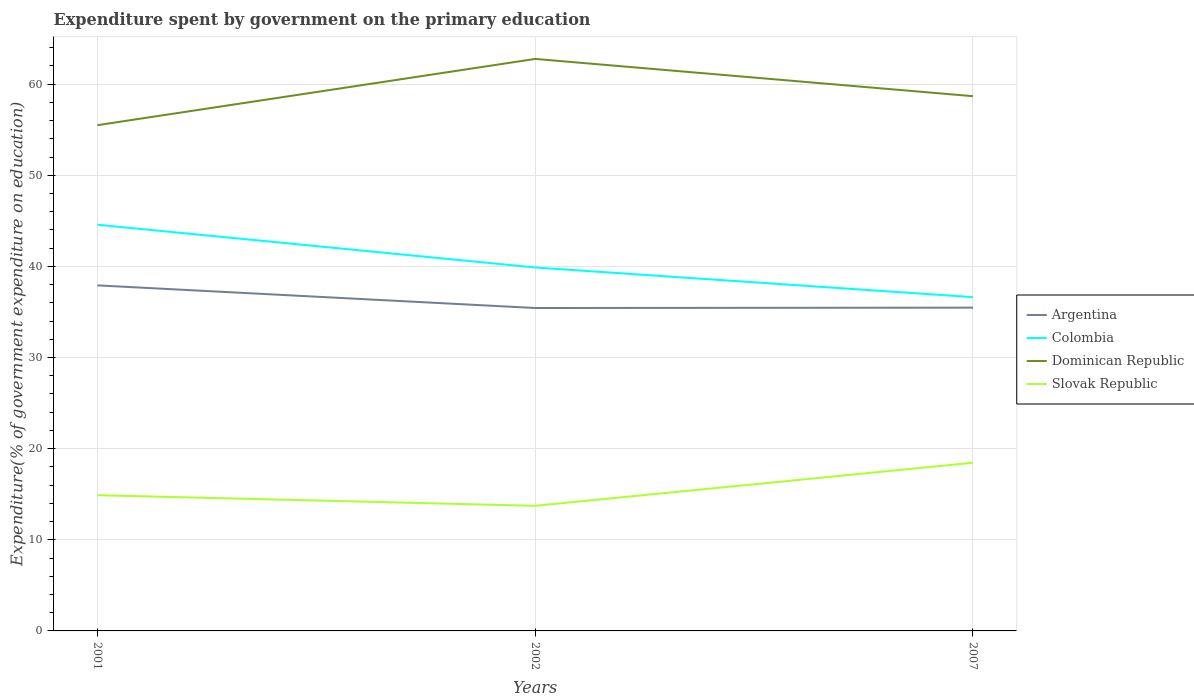Does the line corresponding to Colombia intersect with the line corresponding to Argentina?
Your answer should be very brief. No. Is the number of lines equal to the number of legend labels?
Provide a succinct answer. Yes. Across all years, what is the maximum expenditure spent by government on the primary education in Colombia?
Your answer should be very brief. 36.63. In which year was the expenditure spent by government on the primary education in Dominican Republic maximum?
Your response must be concise. 2001. What is the total expenditure spent by government on the primary education in Argentina in the graph?
Provide a short and direct response. 2.48. What is the difference between the highest and the second highest expenditure spent by government on the primary education in Argentina?
Your answer should be compact. 2.48. How many years are there in the graph?
Give a very brief answer. 3. Does the graph contain any zero values?
Provide a short and direct response. No. Does the graph contain grids?
Provide a succinct answer. Yes. Where does the legend appear in the graph?
Your response must be concise. Center right. What is the title of the graph?
Provide a succinct answer. Expenditure spent by government on the primary education. Does "Trinidad and Tobago" appear as one of the legend labels in the graph?
Your response must be concise. No. What is the label or title of the X-axis?
Offer a very short reply. Years. What is the label or title of the Y-axis?
Your response must be concise. Expenditure(% of government expenditure on education). What is the Expenditure(% of government expenditure on education) of Argentina in 2001?
Offer a very short reply. 37.92. What is the Expenditure(% of government expenditure on education) in Colombia in 2001?
Offer a very short reply. 44.57. What is the Expenditure(% of government expenditure on education) of Dominican Republic in 2001?
Provide a short and direct response. 55.5. What is the Expenditure(% of government expenditure on education) in Slovak Republic in 2001?
Your response must be concise. 14.89. What is the Expenditure(% of government expenditure on education) of Argentina in 2002?
Provide a short and direct response. 35.43. What is the Expenditure(% of government expenditure on education) of Colombia in 2002?
Ensure brevity in your answer.  39.88. What is the Expenditure(% of government expenditure on education) of Dominican Republic in 2002?
Make the answer very short. 62.77. What is the Expenditure(% of government expenditure on education) in Slovak Republic in 2002?
Your response must be concise. 13.73. What is the Expenditure(% of government expenditure on education) in Argentina in 2007?
Provide a succinct answer. 35.48. What is the Expenditure(% of government expenditure on education) in Colombia in 2007?
Ensure brevity in your answer.  36.63. What is the Expenditure(% of government expenditure on education) in Dominican Republic in 2007?
Your response must be concise. 58.68. What is the Expenditure(% of government expenditure on education) in Slovak Republic in 2007?
Provide a short and direct response. 18.46. Across all years, what is the maximum Expenditure(% of government expenditure on education) of Argentina?
Offer a very short reply. 37.92. Across all years, what is the maximum Expenditure(% of government expenditure on education) of Colombia?
Ensure brevity in your answer.  44.57. Across all years, what is the maximum Expenditure(% of government expenditure on education) of Dominican Republic?
Ensure brevity in your answer.  62.77. Across all years, what is the maximum Expenditure(% of government expenditure on education) of Slovak Republic?
Your response must be concise. 18.46. Across all years, what is the minimum Expenditure(% of government expenditure on education) of Argentina?
Make the answer very short. 35.43. Across all years, what is the minimum Expenditure(% of government expenditure on education) in Colombia?
Provide a succinct answer. 36.63. Across all years, what is the minimum Expenditure(% of government expenditure on education) in Dominican Republic?
Your answer should be very brief. 55.5. Across all years, what is the minimum Expenditure(% of government expenditure on education) in Slovak Republic?
Your answer should be very brief. 13.73. What is the total Expenditure(% of government expenditure on education) in Argentina in the graph?
Ensure brevity in your answer.  108.83. What is the total Expenditure(% of government expenditure on education) of Colombia in the graph?
Make the answer very short. 121.08. What is the total Expenditure(% of government expenditure on education) in Dominican Republic in the graph?
Offer a very short reply. 176.95. What is the total Expenditure(% of government expenditure on education) of Slovak Republic in the graph?
Provide a short and direct response. 47.08. What is the difference between the Expenditure(% of government expenditure on education) of Argentina in 2001 and that in 2002?
Provide a succinct answer. 2.48. What is the difference between the Expenditure(% of government expenditure on education) of Colombia in 2001 and that in 2002?
Offer a very short reply. 4.69. What is the difference between the Expenditure(% of government expenditure on education) in Dominican Republic in 2001 and that in 2002?
Give a very brief answer. -7.27. What is the difference between the Expenditure(% of government expenditure on education) in Slovak Republic in 2001 and that in 2002?
Keep it short and to the point. 1.16. What is the difference between the Expenditure(% of government expenditure on education) of Argentina in 2001 and that in 2007?
Keep it short and to the point. 2.44. What is the difference between the Expenditure(% of government expenditure on education) of Colombia in 2001 and that in 2007?
Give a very brief answer. 7.94. What is the difference between the Expenditure(% of government expenditure on education) of Dominican Republic in 2001 and that in 2007?
Ensure brevity in your answer.  -3.18. What is the difference between the Expenditure(% of government expenditure on education) in Slovak Republic in 2001 and that in 2007?
Your answer should be compact. -3.56. What is the difference between the Expenditure(% of government expenditure on education) of Argentina in 2002 and that in 2007?
Offer a terse response. -0.04. What is the difference between the Expenditure(% of government expenditure on education) in Colombia in 2002 and that in 2007?
Ensure brevity in your answer.  3.25. What is the difference between the Expenditure(% of government expenditure on education) of Dominican Republic in 2002 and that in 2007?
Give a very brief answer. 4.09. What is the difference between the Expenditure(% of government expenditure on education) of Slovak Republic in 2002 and that in 2007?
Ensure brevity in your answer.  -4.73. What is the difference between the Expenditure(% of government expenditure on education) of Argentina in 2001 and the Expenditure(% of government expenditure on education) of Colombia in 2002?
Provide a short and direct response. -1.96. What is the difference between the Expenditure(% of government expenditure on education) of Argentina in 2001 and the Expenditure(% of government expenditure on education) of Dominican Republic in 2002?
Your response must be concise. -24.85. What is the difference between the Expenditure(% of government expenditure on education) of Argentina in 2001 and the Expenditure(% of government expenditure on education) of Slovak Republic in 2002?
Provide a succinct answer. 24.19. What is the difference between the Expenditure(% of government expenditure on education) in Colombia in 2001 and the Expenditure(% of government expenditure on education) in Dominican Republic in 2002?
Provide a short and direct response. -18.2. What is the difference between the Expenditure(% of government expenditure on education) in Colombia in 2001 and the Expenditure(% of government expenditure on education) in Slovak Republic in 2002?
Offer a very short reply. 30.84. What is the difference between the Expenditure(% of government expenditure on education) of Dominican Republic in 2001 and the Expenditure(% of government expenditure on education) of Slovak Republic in 2002?
Make the answer very short. 41.77. What is the difference between the Expenditure(% of government expenditure on education) in Argentina in 2001 and the Expenditure(% of government expenditure on education) in Colombia in 2007?
Your answer should be compact. 1.29. What is the difference between the Expenditure(% of government expenditure on education) of Argentina in 2001 and the Expenditure(% of government expenditure on education) of Dominican Republic in 2007?
Give a very brief answer. -20.76. What is the difference between the Expenditure(% of government expenditure on education) in Argentina in 2001 and the Expenditure(% of government expenditure on education) in Slovak Republic in 2007?
Give a very brief answer. 19.46. What is the difference between the Expenditure(% of government expenditure on education) in Colombia in 2001 and the Expenditure(% of government expenditure on education) in Dominican Republic in 2007?
Offer a terse response. -14.11. What is the difference between the Expenditure(% of government expenditure on education) of Colombia in 2001 and the Expenditure(% of government expenditure on education) of Slovak Republic in 2007?
Give a very brief answer. 26.12. What is the difference between the Expenditure(% of government expenditure on education) in Dominican Republic in 2001 and the Expenditure(% of government expenditure on education) in Slovak Republic in 2007?
Your answer should be very brief. 37.04. What is the difference between the Expenditure(% of government expenditure on education) of Argentina in 2002 and the Expenditure(% of government expenditure on education) of Colombia in 2007?
Ensure brevity in your answer.  -1.19. What is the difference between the Expenditure(% of government expenditure on education) in Argentina in 2002 and the Expenditure(% of government expenditure on education) in Dominican Republic in 2007?
Provide a short and direct response. -23.25. What is the difference between the Expenditure(% of government expenditure on education) in Argentina in 2002 and the Expenditure(% of government expenditure on education) in Slovak Republic in 2007?
Offer a very short reply. 16.98. What is the difference between the Expenditure(% of government expenditure on education) in Colombia in 2002 and the Expenditure(% of government expenditure on education) in Dominican Republic in 2007?
Your response must be concise. -18.8. What is the difference between the Expenditure(% of government expenditure on education) in Colombia in 2002 and the Expenditure(% of government expenditure on education) in Slovak Republic in 2007?
Ensure brevity in your answer.  21.43. What is the difference between the Expenditure(% of government expenditure on education) in Dominican Republic in 2002 and the Expenditure(% of government expenditure on education) in Slovak Republic in 2007?
Offer a terse response. 44.31. What is the average Expenditure(% of government expenditure on education) in Argentina per year?
Give a very brief answer. 36.28. What is the average Expenditure(% of government expenditure on education) in Colombia per year?
Give a very brief answer. 40.36. What is the average Expenditure(% of government expenditure on education) in Dominican Republic per year?
Provide a succinct answer. 58.98. What is the average Expenditure(% of government expenditure on education) in Slovak Republic per year?
Ensure brevity in your answer.  15.69. In the year 2001, what is the difference between the Expenditure(% of government expenditure on education) of Argentina and Expenditure(% of government expenditure on education) of Colombia?
Offer a very short reply. -6.65. In the year 2001, what is the difference between the Expenditure(% of government expenditure on education) in Argentina and Expenditure(% of government expenditure on education) in Dominican Republic?
Ensure brevity in your answer.  -17.58. In the year 2001, what is the difference between the Expenditure(% of government expenditure on education) in Argentina and Expenditure(% of government expenditure on education) in Slovak Republic?
Ensure brevity in your answer.  23.02. In the year 2001, what is the difference between the Expenditure(% of government expenditure on education) in Colombia and Expenditure(% of government expenditure on education) in Dominican Republic?
Offer a very short reply. -10.93. In the year 2001, what is the difference between the Expenditure(% of government expenditure on education) in Colombia and Expenditure(% of government expenditure on education) in Slovak Republic?
Provide a short and direct response. 29.68. In the year 2001, what is the difference between the Expenditure(% of government expenditure on education) in Dominican Republic and Expenditure(% of government expenditure on education) in Slovak Republic?
Provide a succinct answer. 40.61. In the year 2002, what is the difference between the Expenditure(% of government expenditure on education) in Argentina and Expenditure(% of government expenditure on education) in Colombia?
Offer a very short reply. -4.45. In the year 2002, what is the difference between the Expenditure(% of government expenditure on education) in Argentina and Expenditure(% of government expenditure on education) in Dominican Republic?
Ensure brevity in your answer.  -27.34. In the year 2002, what is the difference between the Expenditure(% of government expenditure on education) of Argentina and Expenditure(% of government expenditure on education) of Slovak Republic?
Provide a succinct answer. 21.7. In the year 2002, what is the difference between the Expenditure(% of government expenditure on education) in Colombia and Expenditure(% of government expenditure on education) in Dominican Republic?
Give a very brief answer. -22.89. In the year 2002, what is the difference between the Expenditure(% of government expenditure on education) in Colombia and Expenditure(% of government expenditure on education) in Slovak Republic?
Your answer should be very brief. 26.15. In the year 2002, what is the difference between the Expenditure(% of government expenditure on education) in Dominican Republic and Expenditure(% of government expenditure on education) in Slovak Republic?
Your response must be concise. 49.04. In the year 2007, what is the difference between the Expenditure(% of government expenditure on education) in Argentina and Expenditure(% of government expenditure on education) in Colombia?
Keep it short and to the point. -1.15. In the year 2007, what is the difference between the Expenditure(% of government expenditure on education) in Argentina and Expenditure(% of government expenditure on education) in Dominican Republic?
Provide a short and direct response. -23.2. In the year 2007, what is the difference between the Expenditure(% of government expenditure on education) of Argentina and Expenditure(% of government expenditure on education) of Slovak Republic?
Offer a very short reply. 17.02. In the year 2007, what is the difference between the Expenditure(% of government expenditure on education) in Colombia and Expenditure(% of government expenditure on education) in Dominican Republic?
Offer a very short reply. -22.05. In the year 2007, what is the difference between the Expenditure(% of government expenditure on education) of Colombia and Expenditure(% of government expenditure on education) of Slovak Republic?
Ensure brevity in your answer.  18.17. In the year 2007, what is the difference between the Expenditure(% of government expenditure on education) of Dominican Republic and Expenditure(% of government expenditure on education) of Slovak Republic?
Offer a very short reply. 40.22. What is the ratio of the Expenditure(% of government expenditure on education) of Argentina in 2001 to that in 2002?
Keep it short and to the point. 1.07. What is the ratio of the Expenditure(% of government expenditure on education) of Colombia in 2001 to that in 2002?
Provide a succinct answer. 1.12. What is the ratio of the Expenditure(% of government expenditure on education) of Dominican Republic in 2001 to that in 2002?
Keep it short and to the point. 0.88. What is the ratio of the Expenditure(% of government expenditure on education) in Slovak Republic in 2001 to that in 2002?
Your response must be concise. 1.08. What is the ratio of the Expenditure(% of government expenditure on education) in Argentina in 2001 to that in 2007?
Give a very brief answer. 1.07. What is the ratio of the Expenditure(% of government expenditure on education) of Colombia in 2001 to that in 2007?
Offer a very short reply. 1.22. What is the ratio of the Expenditure(% of government expenditure on education) in Dominican Republic in 2001 to that in 2007?
Provide a succinct answer. 0.95. What is the ratio of the Expenditure(% of government expenditure on education) in Slovak Republic in 2001 to that in 2007?
Your response must be concise. 0.81. What is the ratio of the Expenditure(% of government expenditure on education) in Colombia in 2002 to that in 2007?
Your answer should be very brief. 1.09. What is the ratio of the Expenditure(% of government expenditure on education) in Dominican Republic in 2002 to that in 2007?
Offer a very short reply. 1.07. What is the ratio of the Expenditure(% of government expenditure on education) in Slovak Republic in 2002 to that in 2007?
Provide a succinct answer. 0.74. What is the difference between the highest and the second highest Expenditure(% of government expenditure on education) of Argentina?
Provide a short and direct response. 2.44. What is the difference between the highest and the second highest Expenditure(% of government expenditure on education) of Colombia?
Your response must be concise. 4.69. What is the difference between the highest and the second highest Expenditure(% of government expenditure on education) of Dominican Republic?
Provide a short and direct response. 4.09. What is the difference between the highest and the second highest Expenditure(% of government expenditure on education) of Slovak Republic?
Provide a short and direct response. 3.56. What is the difference between the highest and the lowest Expenditure(% of government expenditure on education) of Argentina?
Provide a short and direct response. 2.48. What is the difference between the highest and the lowest Expenditure(% of government expenditure on education) of Colombia?
Offer a terse response. 7.94. What is the difference between the highest and the lowest Expenditure(% of government expenditure on education) in Dominican Republic?
Your answer should be compact. 7.27. What is the difference between the highest and the lowest Expenditure(% of government expenditure on education) of Slovak Republic?
Ensure brevity in your answer.  4.73. 